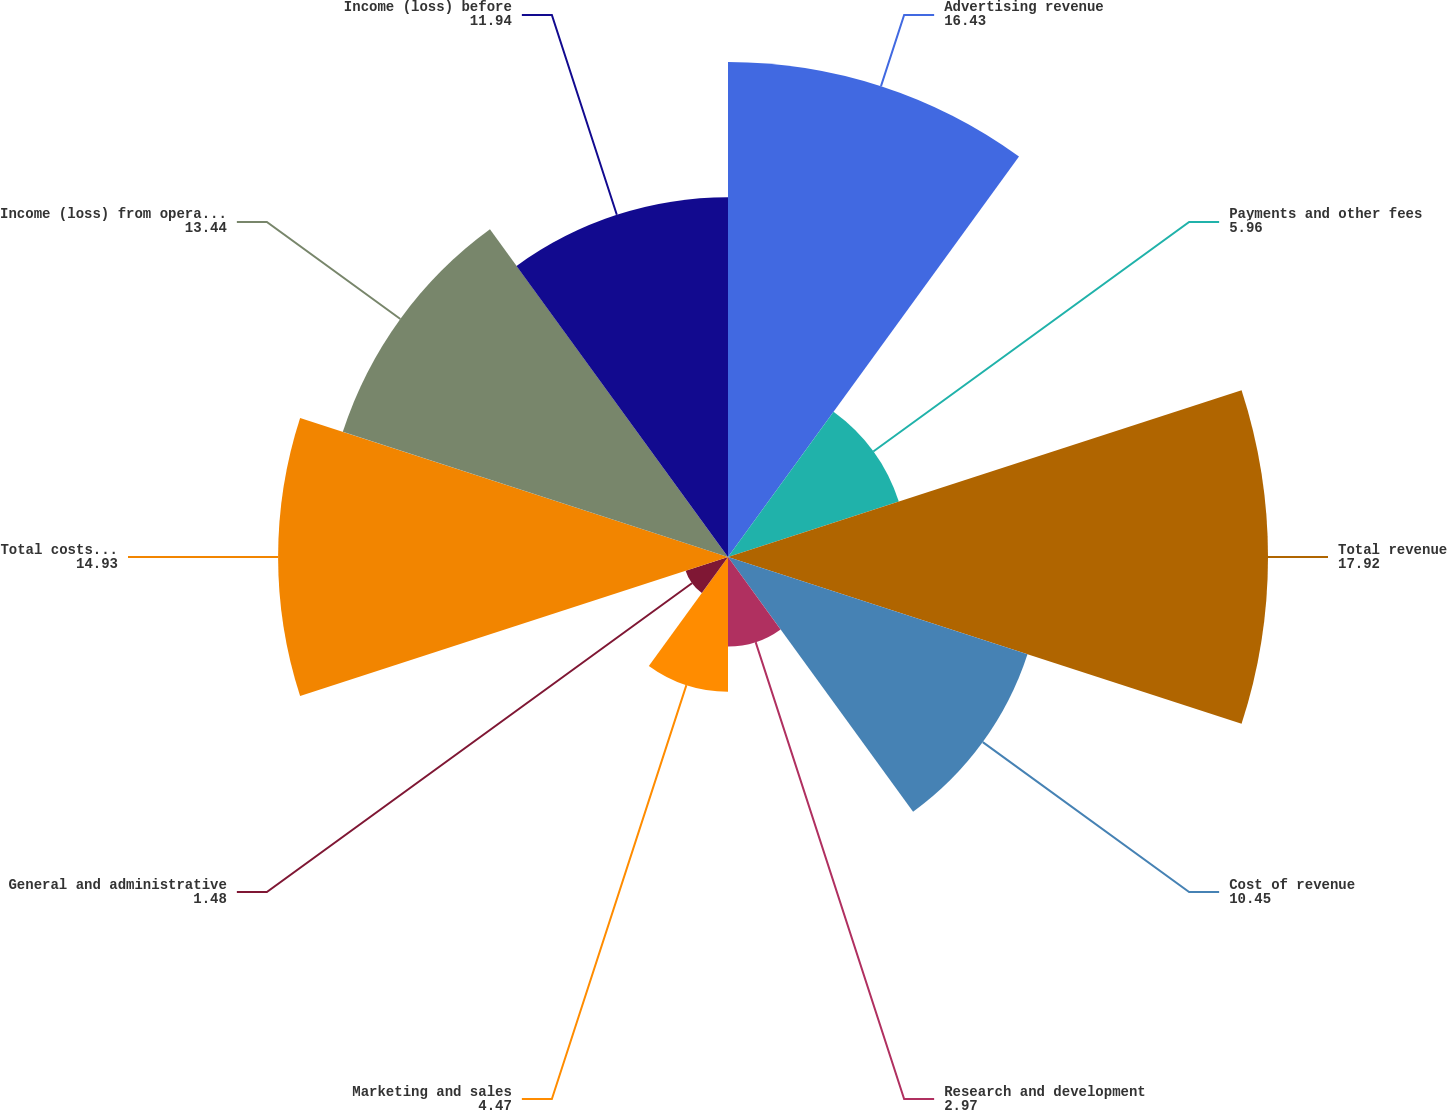<chart> <loc_0><loc_0><loc_500><loc_500><pie_chart><fcel>Advertising revenue<fcel>Payments and other fees<fcel>Total revenue<fcel>Cost of revenue<fcel>Research and development<fcel>Marketing and sales<fcel>General and administrative<fcel>Total costs and expenses<fcel>Income (loss) from operations<fcel>Income (loss) before<nl><fcel>16.43%<fcel>5.96%<fcel>17.92%<fcel>10.45%<fcel>2.97%<fcel>4.47%<fcel>1.48%<fcel>14.93%<fcel>13.44%<fcel>11.94%<nl></chart> 